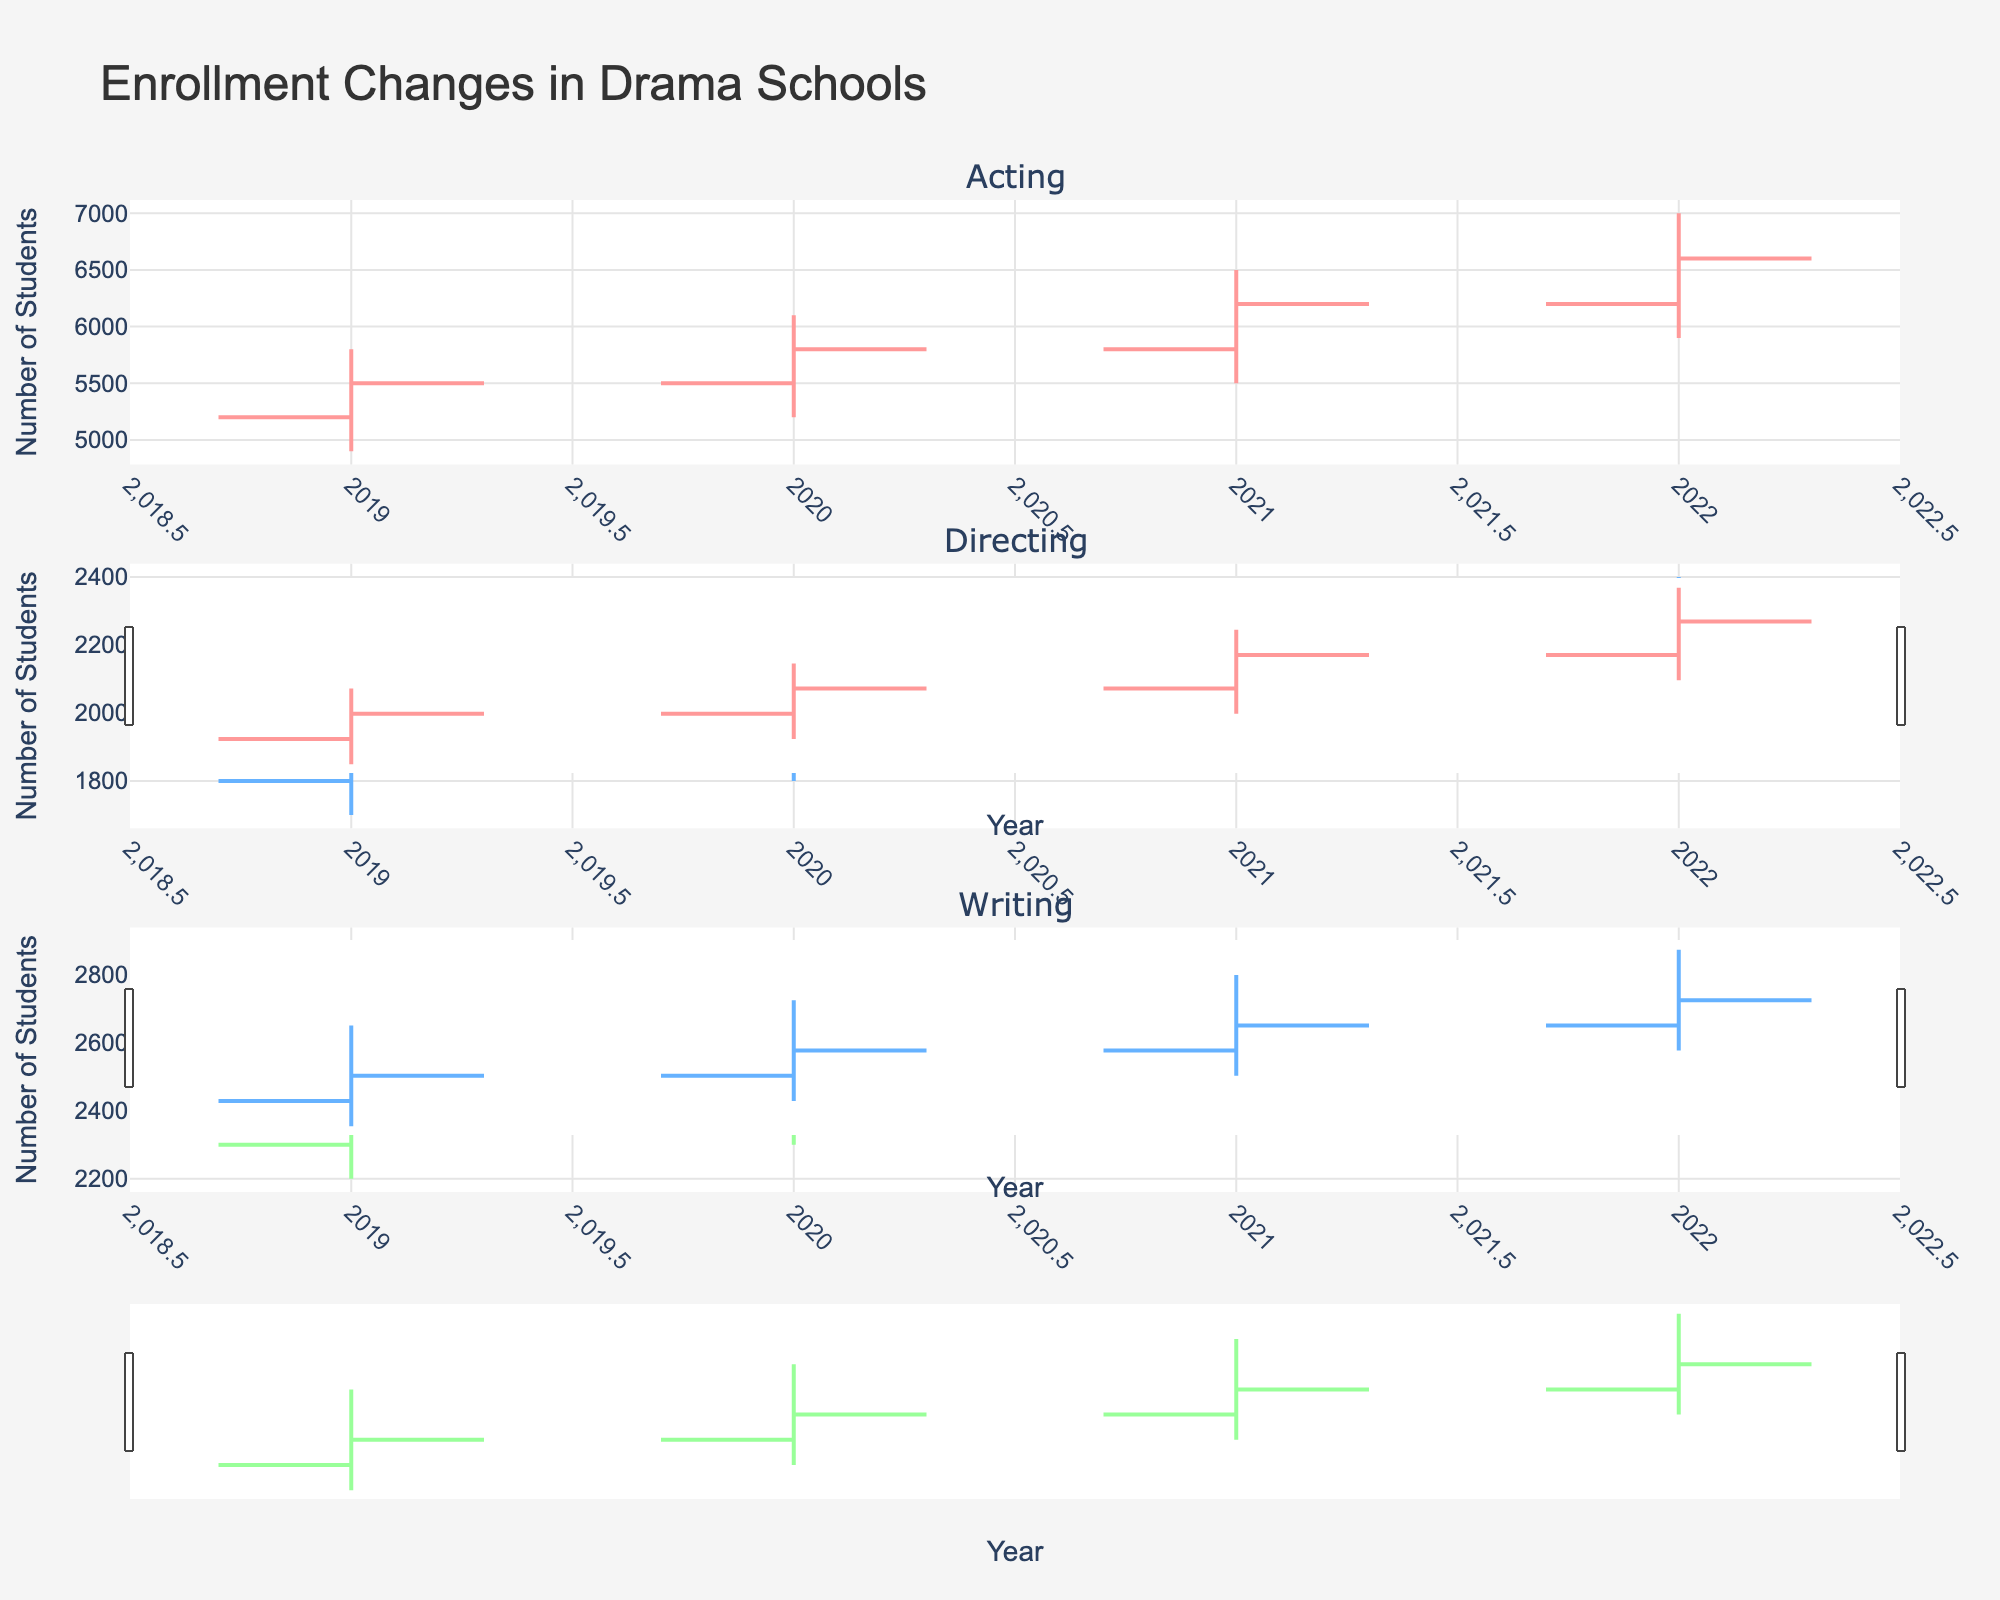How many specializations are covered in the figure? The figure includes different subplots for each specialization in drama schools. Looking at these subplots will tell us the number of specializations.
Answer: 3 Which specialization had the highest number of students at any point from 2019 to 2022? By examining the highest points of the 'High' value in each subplot of the figure, we can identify the specialization with the highest enrollment numbers.
Answer: Acting What was the lowest enrollment number for the Writing specialization in any year? We need to look at the OHLC chart for the Writing specialization and identify the minimum value in the 'Low' series.
Answer: 2200 How did the enrollment numbers for Directing change from 2019 to 2022? Observing the OHLC chart for Directing and comparing the 'Open' value in 2019 with the 'Close' value in 2022 provides the trend.
Answer: Increased from 1800 to 2200 Between which two years did Acting see the highest increase in its closing enrollment numbers? By comparing the 'Close' value for the Acting specialization from year to year, we can identify the year pair with the largest difference.
Answer: 2021 to 2022 In 2021, which specialization had the smallest range (difference between high and low) in student enrollment numbers? By calculating the difference between the 'High' and 'Low' values for each specialization in 2021, we find the one with the smallest range.
Answer: Directing How did the average enrollment numbers for Acting change over the years? Calculate the average of the 'Close' values for the Acting specialization across all years and view the trend.
Answer: Increased Was there any year when the enrollment numbers decreased for Writing compared to the previous year? Compare the 'Close' values for Writing from year to year to check for any decreases.
Answer: No Which specialization consistently had the lowest enrollment numbers from 2019 to 2022? Compare the 'Close' values year by year for all specializations to identify the one with the lowest values consistently.
Answer: Directing 